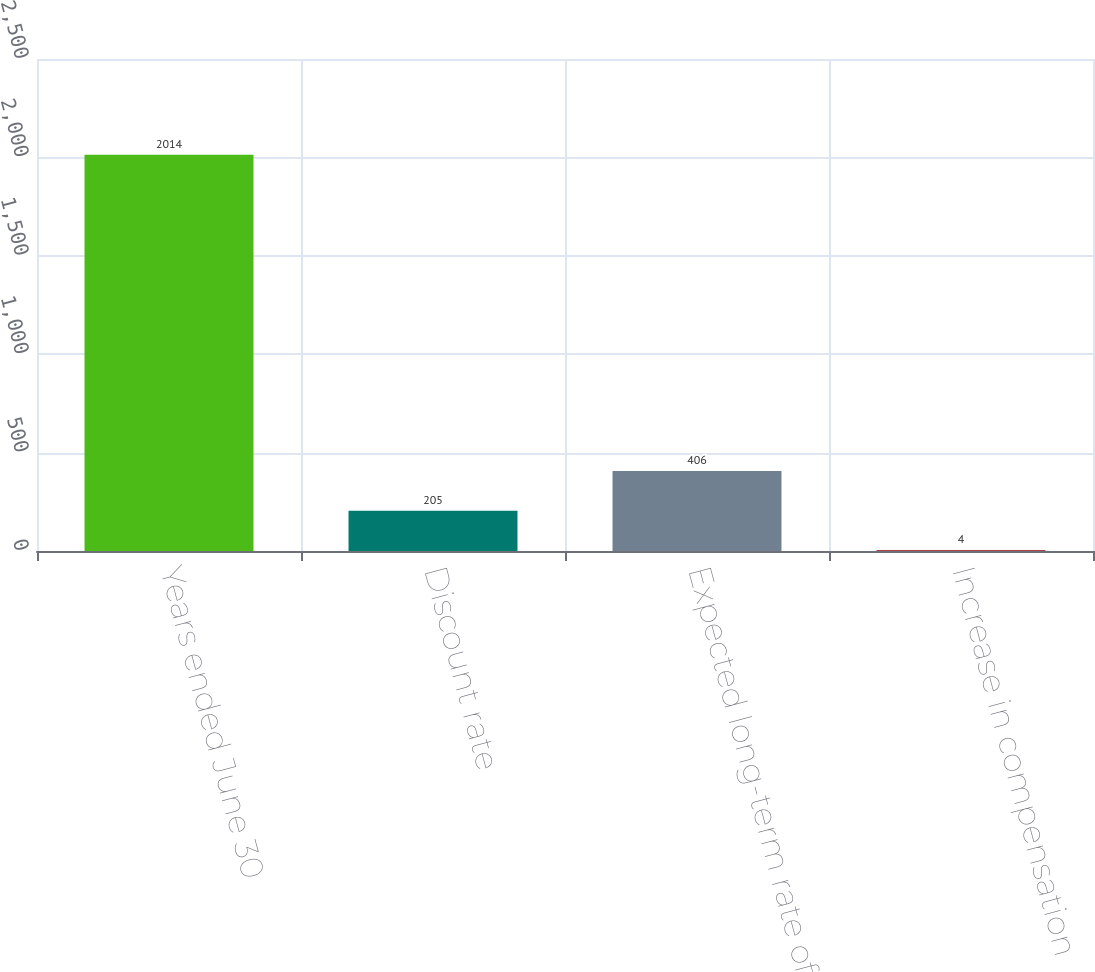Convert chart. <chart><loc_0><loc_0><loc_500><loc_500><bar_chart><fcel>Years ended June 30<fcel>Discount rate<fcel>Expected long-term rate of<fcel>Increase in compensation<nl><fcel>2014<fcel>205<fcel>406<fcel>4<nl></chart> 